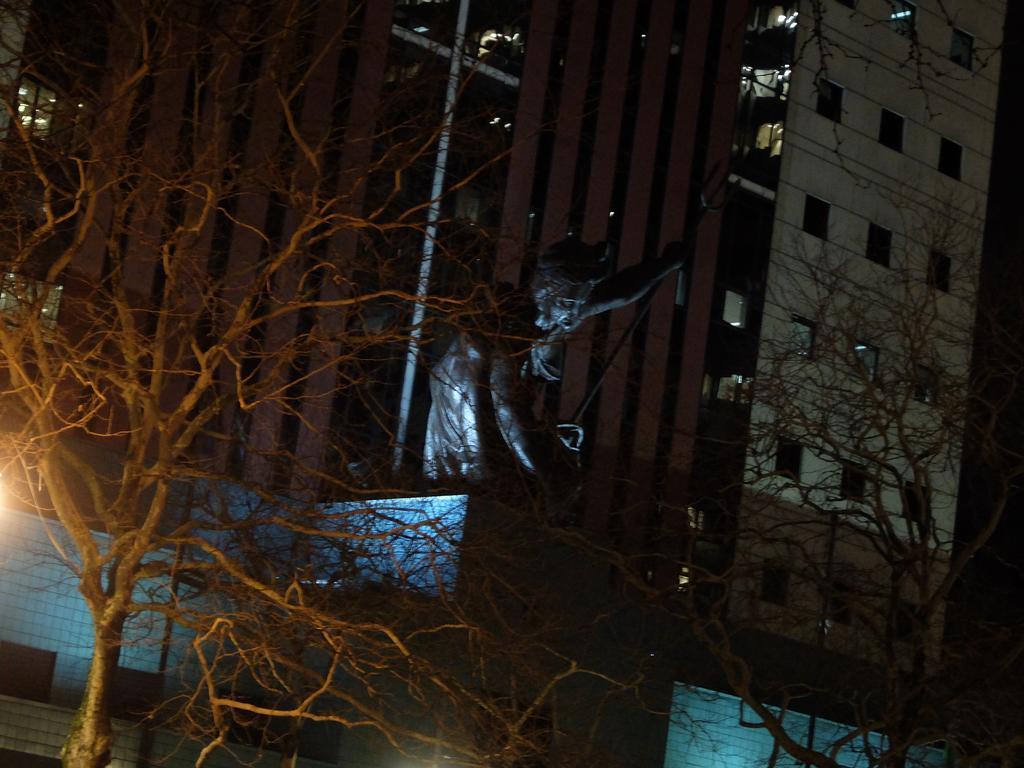Please provide a concise description of this image. In this image there are trees, sculpture of a person, and in the background there is a building. 